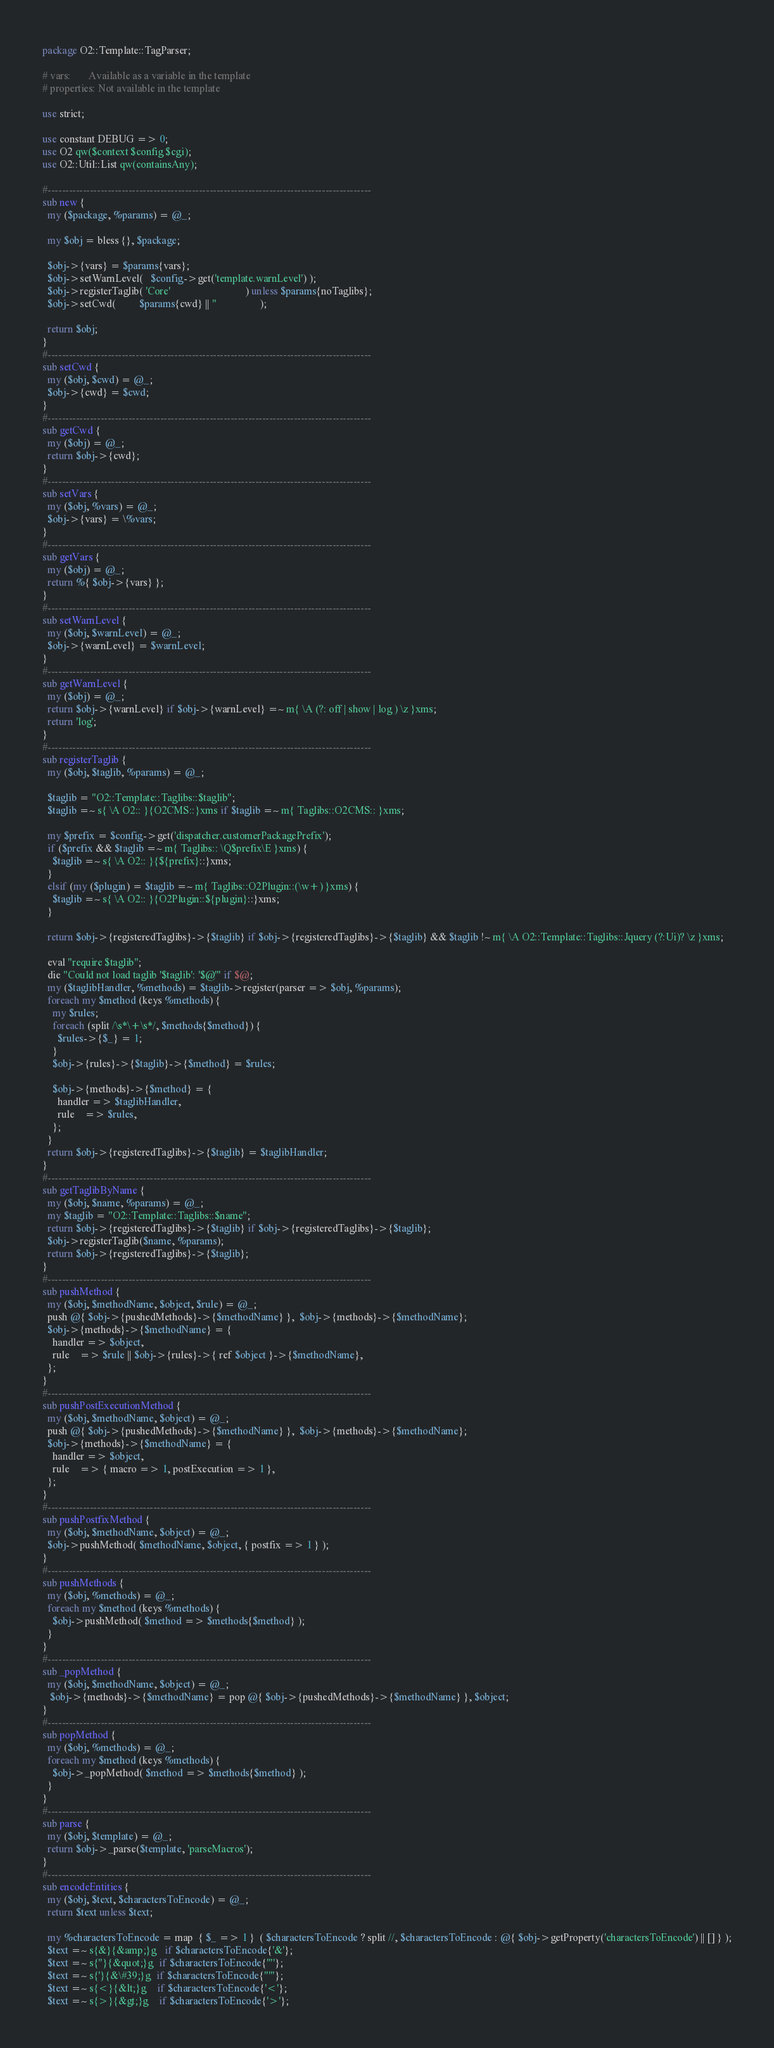<code> <loc_0><loc_0><loc_500><loc_500><_Perl_>package O2::Template::TagParser;

# vars:       Available as a variable in the template
# properties: Not available in the template

use strict;

use constant DEBUG => 0;
use O2 qw($context $config $cgi);
use O2::Util::List qw(containsAny);

#--------------------------------------------------------------------------------------------
sub new {
  my ($package, %params) = @_;
  
  my $obj = bless {}, $package;
  
  $obj->{vars} = $params{vars};
  $obj->setWarnLevel(   $config->get('template.warnLevel') );
  $obj->registerTaglib( 'Core'                             ) unless $params{noTaglibs};
  $obj->setCwd(         $params{cwd} || ''                 );
  
  return $obj;
}
#--------------------------------------------------------------------------------------------
sub setCwd {
  my ($obj, $cwd) = @_;
  $obj->{cwd} = $cwd;
}
#--------------------------------------------------------------------------------------------
sub getCwd {
  my ($obj) = @_;
  return $obj->{cwd};
}
#--------------------------------------------------------------------------------------------
sub setVars {
  my ($obj, %vars) = @_;
  $obj->{vars} = \%vars;
}
#--------------------------------------------------------------------------------------------
sub getVars {
  my ($obj) = @_;
  return %{ $obj->{vars} };
}
#--------------------------------------------------------------------------------------------
sub setWarnLevel {
  my ($obj, $warnLevel) = @_;
  $obj->{warnLevel} = $warnLevel;
}
#--------------------------------------------------------------------------------------------
sub getWarnLevel {
  my ($obj) = @_;
  return $obj->{warnLevel} if $obj->{warnLevel} =~ m{ \A (?: off | show | log ) \z }xms;
  return 'log';
}
#--------------------------------------------------------------------------------------------
sub registerTaglib {
  my ($obj, $taglib, %params) = @_;
  
  $taglib = "O2::Template::Taglibs::$taglib";
  $taglib =~ s{ \A O2:: }{O2CMS::}xms if $taglib =~ m{ Taglibs::O2CMS:: }xms;
  
  my $prefix = $config->get('dispatcher.customerPackagePrefix');
  if ($prefix && $taglib =~ m{ Taglibs:: \Q$prefix\E }xms) {
    $taglib =~ s{ \A O2:: }{${prefix}::}xms;
  }
  elsif (my ($plugin) = $taglib =~ m{ Taglibs::O2Plugin::(\w+) }xms) {
    $taglib =~ s{ \A O2:: }{O2Plugin::${plugin}::}xms;
  }
  
  return $obj->{registeredTaglibs}->{$taglib} if $obj->{registeredTaglibs}->{$taglib} && $taglib !~ m{ \A O2::Template::Taglibs::Jquery (?:Ui)? \z }xms;
  
  eval "require $taglib";
  die "Could not load taglib '$taglib': '$@'" if $@;
  my ($taglibHandler, %methods) = $taglib->register(parser => $obj, %params);
  foreach my $method (keys %methods) {
    my $rules;
    foreach (split /\s*\+\s*/, $methods{$method}) {
      $rules->{$_} = 1;
    }
    $obj->{rules}->{$taglib}->{$method} = $rules;
    
    $obj->{methods}->{$method} = {
      handler => $taglibHandler,
      rule    => $rules,
    };
  }
  return $obj->{registeredTaglibs}->{$taglib} = $taglibHandler;
}
#--------------------------------------------------------------------------------------------
sub getTaglibByName {
  my ($obj, $name, %params) = @_;
  my $taglib = "O2::Template::Taglibs::$name";
  return $obj->{registeredTaglibs}->{$taglib} if $obj->{registeredTaglibs}->{$taglib};
  $obj->registerTaglib($name, %params);
  return $obj->{registeredTaglibs}->{$taglib};
}
#--------------------------------------------------------------------------------------------
sub pushMethod {
  my ($obj, $methodName, $object, $rule) = @_;
  push @{ $obj->{pushedMethods}->{$methodName} },  $obj->{methods}->{$methodName};
  $obj->{methods}->{$methodName} = {
    handler => $object,
    rule    => $rule || $obj->{rules}->{ ref $object }->{$methodName},
  };
}
#--------------------------------------------------------------------------------------------
sub pushPostExecutionMethod {
  my ($obj, $methodName, $object) = @_;
  push @{ $obj->{pushedMethods}->{$methodName} },  $obj->{methods}->{$methodName};
  $obj->{methods}->{$methodName} = {
    handler => $object,
    rule    => { macro => 1, postExecution => 1 },
  };
}
#--------------------------------------------------------------------------------------------
sub pushPostfixMethod {
  my ($obj, $methodName, $object) = @_;
  $obj->pushMethod( $methodName, $object, { postfix => 1 } );
}
#--------------------------------------------------------------------------------------------
sub pushMethods {
  my ($obj, %methods) = @_;
  foreach my $method (keys %methods) {
    $obj->pushMethod( $method => $methods{$method} );
  }
}
#--------------------------------------------------------------------------------------------
sub _popMethod {
  my ($obj, $methodName, $object) = @_;
   $obj->{methods}->{$methodName} = pop @{ $obj->{pushedMethods}->{$methodName} }, $object;
}
#--------------------------------------------------------------------------------------------
sub popMethod {
  my ($obj, %methods) = @_;
  foreach my $method (keys %methods) {
    $obj->_popMethod( $method => $methods{$method} );
  }
}
#--------------------------------------------------------------------------------------------
sub parse {
  my ($obj, $template) = @_;
  return $obj->_parse($template, 'parseMacros');
}
#--------------------------------------------------------------------------------------------
sub encodeEntities {
  my ($obj, $text, $charactersToEncode) = @_;
  return $text unless $text;
  
  my %charactersToEncode = map  { $_ => 1 }  ( $charactersToEncode ? split //, $charactersToEncode : @{ $obj->getProperty('charactersToEncode') || [] } );
  $text =~ s{&}{&amp;}g   if $charactersToEncode{'&'};
  $text =~ s{"}{&quot;}g  if $charactersToEncode{'"'};
  $text =~ s{'}{&\#39;}g  if $charactersToEncode{"'"};
  $text =~ s{<}{&lt;}g    if $charactersToEncode{'<'};
  $text =~ s{>}{&gt;}g    if $charactersToEncode{'>'};</code> 